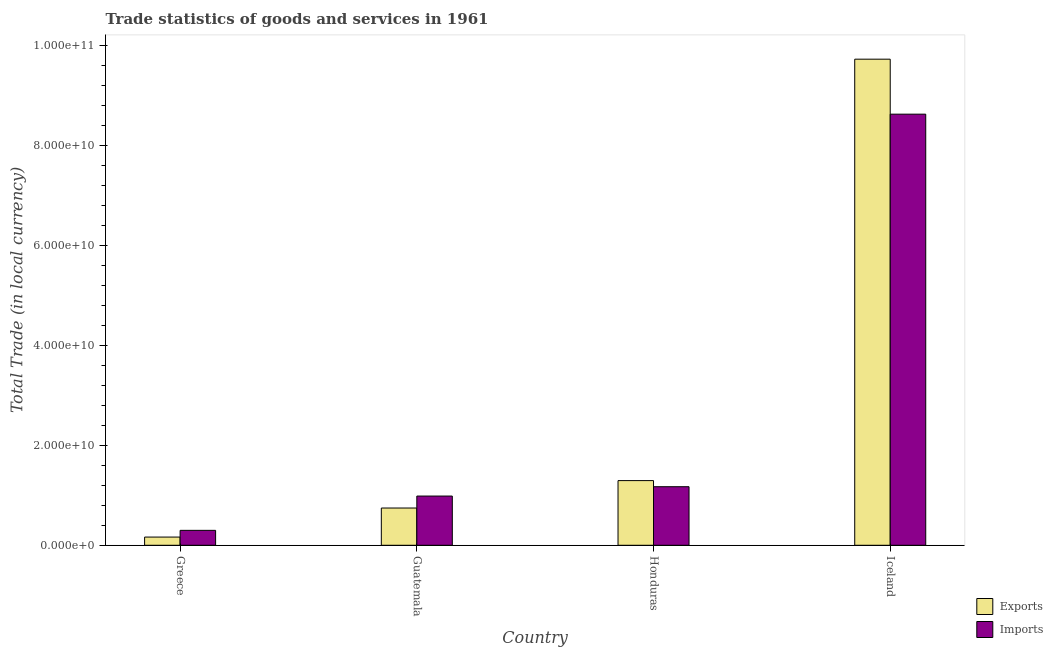How many different coloured bars are there?
Provide a succinct answer. 2. What is the label of the 1st group of bars from the left?
Keep it short and to the point. Greece. What is the export of goods and services in Honduras?
Make the answer very short. 1.30e+1. Across all countries, what is the maximum export of goods and services?
Your answer should be compact. 9.74e+1. Across all countries, what is the minimum imports of goods and services?
Offer a terse response. 2.99e+09. What is the total export of goods and services in the graph?
Your answer should be compact. 1.19e+11. What is the difference between the export of goods and services in Greece and that in Honduras?
Offer a very short reply. -1.13e+1. What is the difference between the export of goods and services in Greece and the imports of goods and services in Guatemala?
Offer a very short reply. -8.22e+09. What is the average imports of goods and services per country?
Keep it short and to the point. 2.77e+1. What is the difference between the export of goods and services and imports of goods and services in Honduras?
Your answer should be very brief. 1.22e+09. What is the ratio of the export of goods and services in Greece to that in Iceland?
Offer a very short reply. 0.02. What is the difference between the highest and the second highest export of goods and services?
Keep it short and to the point. 8.44e+1. What is the difference between the highest and the lowest imports of goods and services?
Provide a short and direct response. 8.34e+1. In how many countries, is the export of goods and services greater than the average export of goods and services taken over all countries?
Make the answer very short. 1. What does the 1st bar from the left in Guatemala represents?
Make the answer very short. Exports. What does the 2nd bar from the right in Greece represents?
Make the answer very short. Exports. Are all the bars in the graph horizontal?
Make the answer very short. No. What is the difference between two consecutive major ticks on the Y-axis?
Your response must be concise. 2.00e+1. Are the values on the major ticks of Y-axis written in scientific E-notation?
Keep it short and to the point. Yes. Does the graph contain any zero values?
Your answer should be compact. No. Does the graph contain grids?
Offer a terse response. No. Where does the legend appear in the graph?
Ensure brevity in your answer.  Bottom right. How are the legend labels stacked?
Your response must be concise. Vertical. What is the title of the graph?
Provide a short and direct response. Trade statistics of goods and services in 1961. Does "Register a business" appear as one of the legend labels in the graph?
Your answer should be compact. No. What is the label or title of the X-axis?
Give a very brief answer. Country. What is the label or title of the Y-axis?
Provide a succinct answer. Total Trade (in local currency). What is the Total Trade (in local currency) of Exports in Greece?
Your answer should be compact. 1.64e+09. What is the Total Trade (in local currency) of Imports in Greece?
Your response must be concise. 2.99e+09. What is the Total Trade (in local currency) in Exports in Guatemala?
Give a very brief answer. 7.46e+09. What is the Total Trade (in local currency) in Imports in Guatemala?
Provide a succinct answer. 9.86e+09. What is the Total Trade (in local currency) in Exports in Honduras?
Keep it short and to the point. 1.30e+1. What is the Total Trade (in local currency) in Imports in Honduras?
Make the answer very short. 1.17e+1. What is the Total Trade (in local currency) of Exports in Iceland?
Give a very brief answer. 9.74e+1. What is the Total Trade (in local currency) in Imports in Iceland?
Make the answer very short. 8.63e+1. Across all countries, what is the maximum Total Trade (in local currency) in Exports?
Your answer should be very brief. 9.74e+1. Across all countries, what is the maximum Total Trade (in local currency) in Imports?
Offer a very short reply. 8.63e+1. Across all countries, what is the minimum Total Trade (in local currency) of Exports?
Keep it short and to the point. 1.64e+09. Across all countries, what is the minimum Total Trade (in local currency) of Imports?
Your answer should be compact. 2.99e+09. What is the total Total Trade (in local currency) of Exports in the graph?
Offer a very short reply. 1.19e+11. What is the total Total Trade (in local currency) of Imports in the graph?
Make the answer very short. 1.11e+11. What is the difference between the Total Trade (in local currency) in Exports in Greece and that in Guatemala?
Offer a terse response. -5.82e+09. What is the difference between the Total Trade (in local currency) in Imports in Greece and that in Guatemala?
Provide a succinct answer. -6.87e+09. What is the difference between the Total Trade (in local currency) of Exports in Greece and that in Honduras?
Your response must be concise. -1.13e+1. What is the difference between the Total Trade (in local currency) of Imports in Greece and that in Honduras?
Offer a terse response. -8.74e+09. What is the difference between the Total Trade (in local currency) in Exports in Greece and that in Iceland?
Ensure brevity in your answer.  -9.57e+1. What is the difference between the Total Trade (in local currency) of Imports in Greece and that in Iceland?
Your answer should be very brief. -8.34e+1. What is the difference between the Total Trade (in local currency) in Exports in Guatemala and that in Honduras?
Your answer should be very brief. -5.49e+09. What is the difference between the Total Trade (in local currency) of Imports in Guatemala and that in Honduras?
Offer a terse response. -1.87e+09. What is the difference between the Total Trade (in local currency) in Exports in Guatemala and that in Iceland?
Your answer should be compact. -8.99e+1. What is the difference between the Total Trade (in local currency) of Imports in Guatemala and that in Iceland?
Keep it short and to the point. -7.65e+1. What is the difference between the Total Trade (in local currency) of Exports in Honduras and that in Iceland?
Your answer should be compact. -8.44e+1. What is the difference between the Total Trade (in local currency) of Imports in Honduras and that in Iceland?
Your answer should be very brief. -7.46e+1. What is the difference between the Total Trade (in local currency) of Exports in Greece and the Total Trade (in local currency) of Imports in Guatemala?
Provide a succinct answer. -8.22e+09. What is the difference between the Total Trade (in local currency) of Exports in Greece and the Total Trade (in local currency) of Imports in Honduras?
Provide a short and direct response. -1.01e+1. What is the difference between the Total Trade (in local currency) of Exports in Greece and the Total Trade (in local currency) of Imports in Iceland?
Your response must be concise. -8.47e+1. What is the difference between the Total Trade (in local currency) of Exports in Guatemala and the Total Trade (in local currency) of Imports in Honduras?
Make the answer very short. -4.27e+09. What is the difference between the Total Trade (in local currency) of Exports in Guatemala and the Total Trade (in local currency) of Imports in Iceland?
Give a very brief answer. -7.89e+1. What is the difference between the Total Trade (in local currency) in Exports in Honduras and the Total Trade (in local currency) in Imports in Iceland?
Ensure brevity in your answer.  -7.34e+1. What is the average Total Trade (in local currency) of Exports per country?
Your answer should be very brief. 2.99e+1. What is the average Total Trade (in local currency) of Imports per country?
Your answer should be very brief. 2.77e+1. What is the difference between the Total Trade (in local currency) in Exports and Total Trade (in local currency) in Imports in Greece?
Your answer should be very brief. -1.35e+09. What is the difference between the Total Trade (in local currency) in Exports and Total Trade (in local currency) in Imports in Guatemala?
Provide a short and direct response. -2.40e+09. What is the difference between the Total Trade (in local currency) in Exports and Total Trade (in local currency) in Imports in Honduras?
Provide a short and direct response. 1.22e+09. What is the difference between the Total Trade (in local currency) in Exports and Total Trade (in local currency) in Imports in Iceland?
Keep it short and to the point. 1.10e+1. What is the ratio of the Total Trade (in local currency) in Exports in Greece to that in Guatemala?
Your answer should be very brief. 0.22. What is the ratio of the Total Trade (in local currency) in Imports in Greece to that in Guatemala?
Keep it short and to the point. 0.3. What is the ratio of the Total Trade (in local currency) of Exports in Greece to that in Honduras?
Make the answer very short. 0.13. What is the ratio of the Total Trade (in local currency) of Imports in Greece to that in Honduras?
Your response must be concise. 0.25. What is the ratio of the Total Trade (in local currency) of Exports in Greece to that in Iceland?
Offer a very short reply. 0.02. What is the ratio of the Total Trade (in local currency) in Imports in Greece to that in Iceland?
Ensure brevity in your answer.  0.03. What is the ratio of the Total Trade (in local currency) in Exports in Guatemala to that in Honduras?
Offer a terse response. 0.58. What is the ratio of the Total Trade (in local currency) in Imports in Guatemala to that in Honduras?
Make the answer very short. 0.84. What is the ratio of the Total Trade (in local currency) in Exports in Guatemala to that in Iceland?
Your answer should be very brief. 0.08. What is the ratio of the Total Trade (in local currency) in Imports in Guatemala to that in Iceland?
Provide a short and direct response. 0.11. What is the ratio of the Total Trade (in local currency) of Exports in Honduras to that in Iceland?
Make the answer very short. 0.13. What is the ratio of the Total Trade (in local currency) of Imports in Honduras to that in Iceland?
Provide a succinct answer. 0.14. What is the difference between the highest and the second highest Total Trade (in local currency) of Exports?
Make the answer very short. 8.44e+1. What is the difference between the highest and the second highest Total Trade (in local currency) of Imports?
Your answer should be compact. 7.46e+1. What is the difference between the highest and the lowest Total Trade (in local currency) in Exports?
Offer a terse response. 9.57e+1. What is the difference between the highest and the lowest Total Trade (in local currency) of Imports?
Offer a terse response. 8.34e+1. 